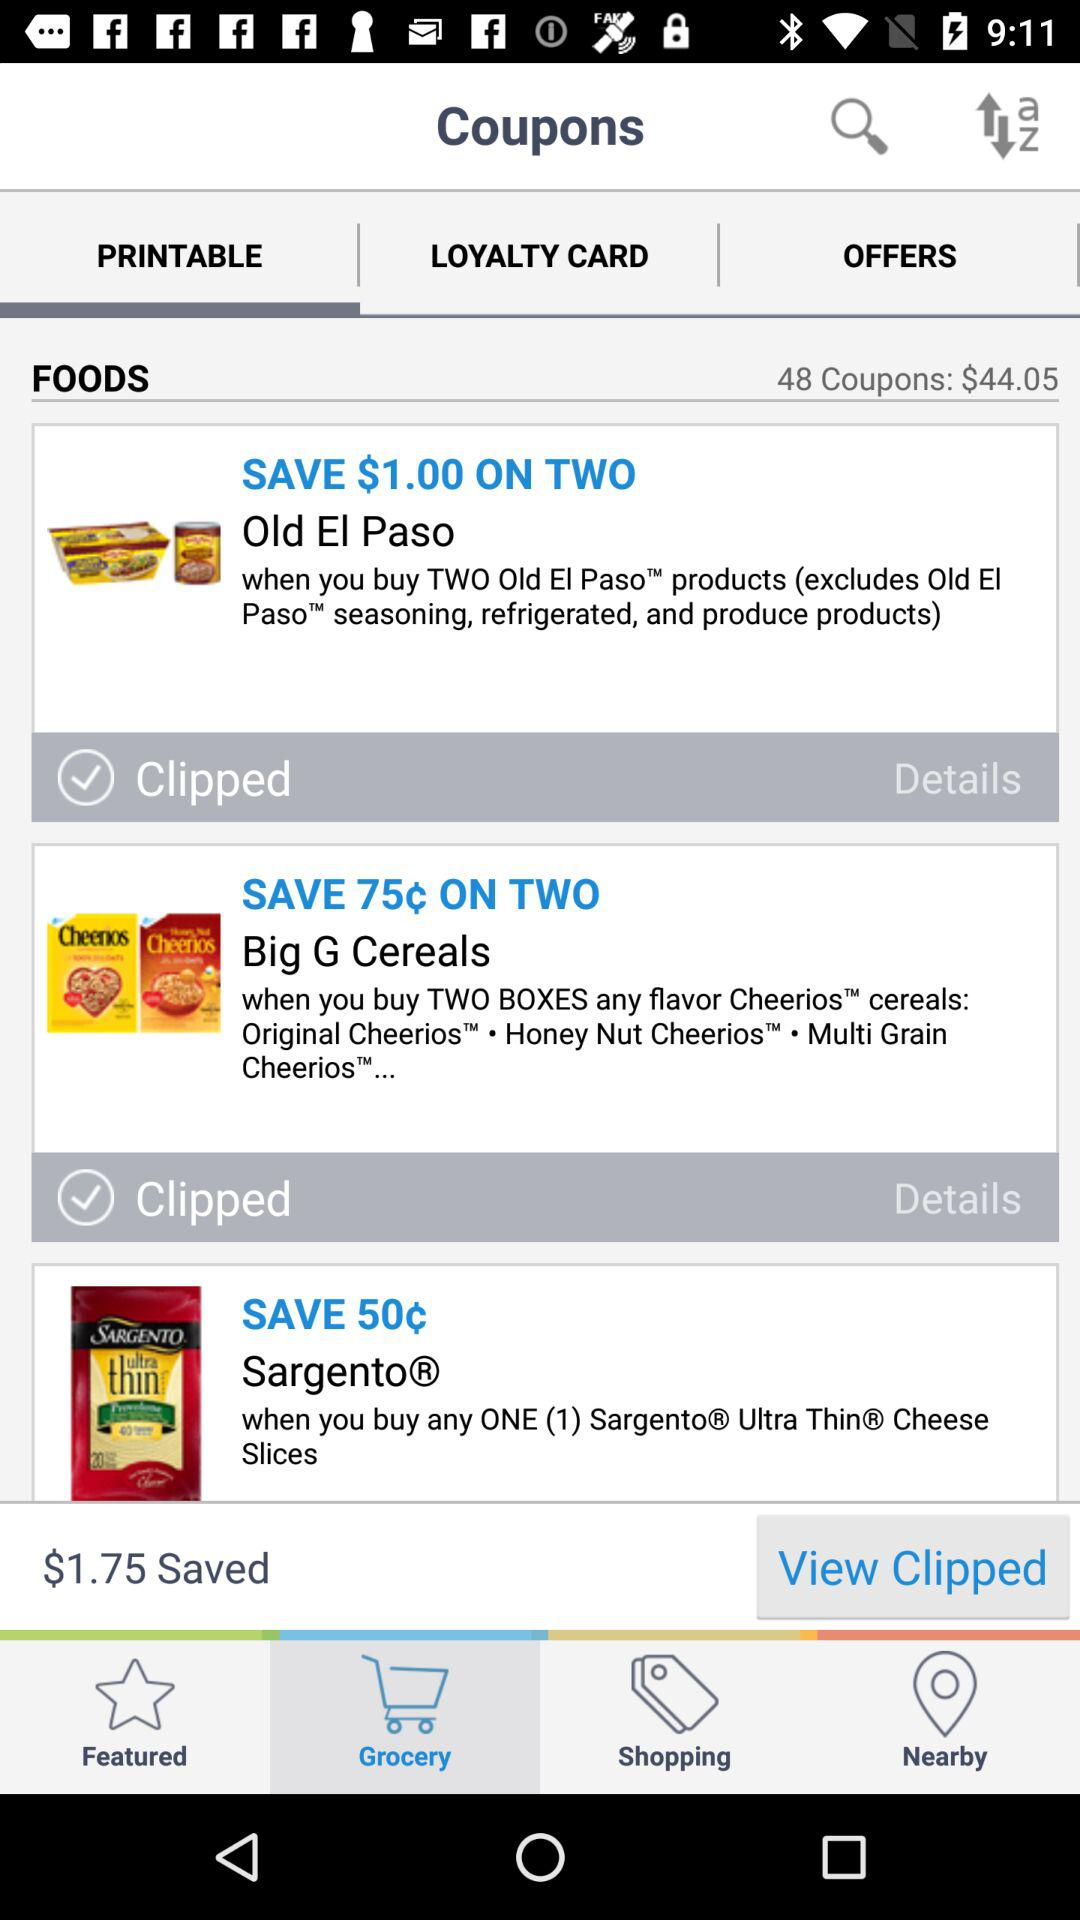How many coupons are for products that are not Old El Paso?
Answer the question using a single word or phrase. 2 